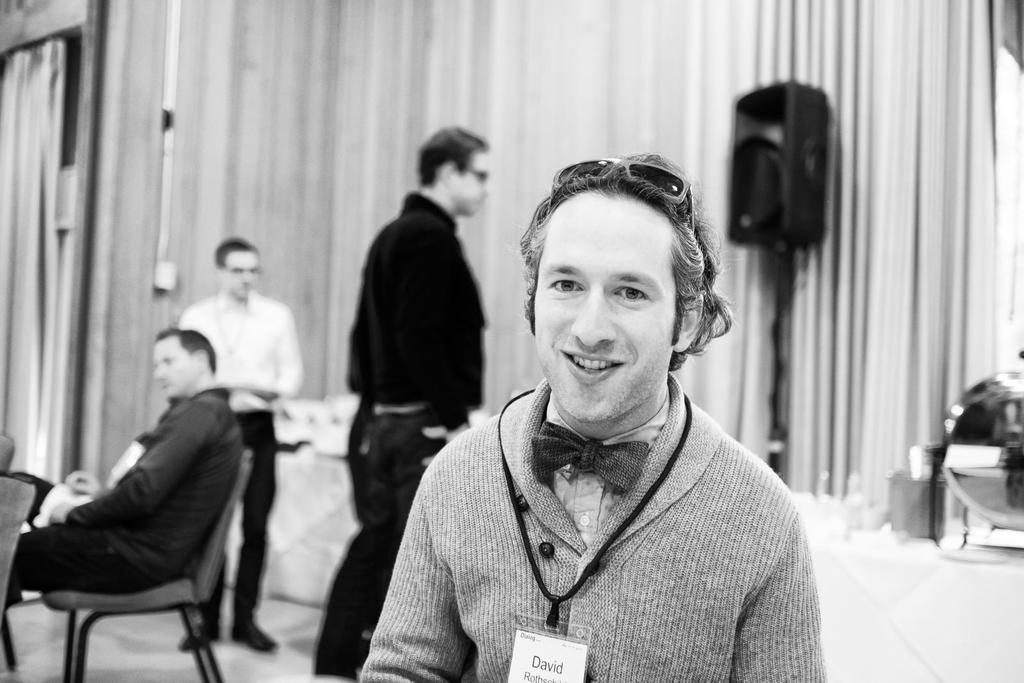In one or two sentences, can you explain what this image depicts? In the picture I can see a person smiling and there are two person standing behind him and there is a person sitting in the chair in the left corner and there are few other objects in the background. 